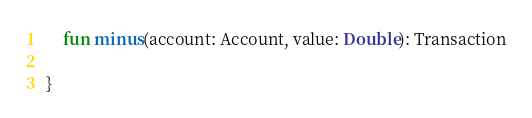<code> <loc_0><loc_0><loc_500><loc_500><_Kotlin_>    fun minus(account: Account, value: Double): Transaction

}</code> 